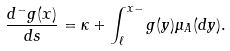Convert formula to latex. <formula><loc_0><loc_0><loc_500><loc_500>\frac { d ^ { - } g ( x ) } { d s } = \kappa + \int _ { \ell } ^ { x - } g ( y ) \mu _ { A } ( d y ) .</formula> 